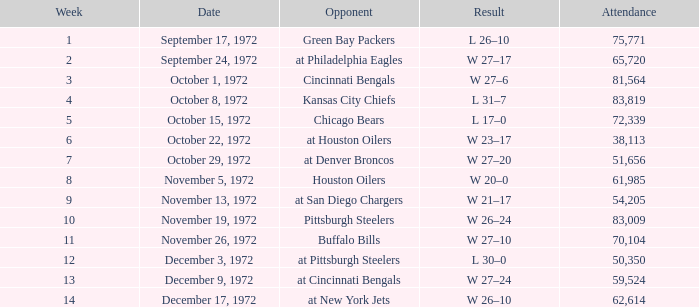What is the combined sum of the week number(s) where the attendance was 61,985? 1.0. 